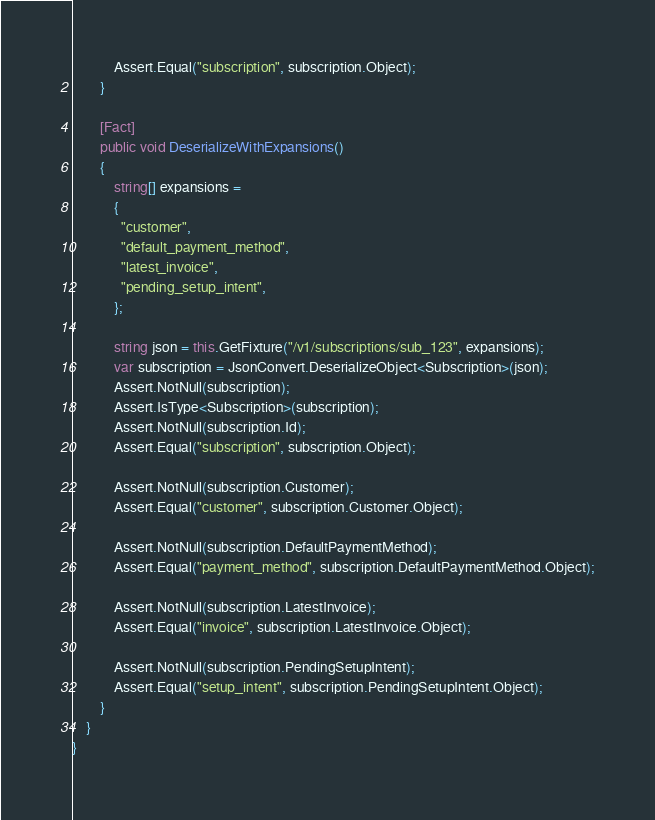<code> <loc_0><loc_0><loc_500><loc_500><_C#_>            Assert.Equal("subscription", subscription.Object);
        }

        [Fact]
        public void DeserializeWithExpansions()
        {
            string[] expansions =
            {
              "customer",
              "default_payment_method",
              "latest_invoice",
              "pending_setup_intent",
            };

            string json = this.GetFixture("/v1/subscriptions/sub_123", expansions);
            var subscription = JsonConvert.DeserializeObject<Subscription>(json);
            Assert.NotNull(subscription);
            Assert.IsType<Subscription>(subscription);
            Assert.NotNull(subscription.Id);
            Assert.Equal("subscription", subscription.Object);

            Assert.NotNull(subscription.Customer);
            Assert.Equal("customer", subscription.Customer.Object);

            Assert.NotNull(subscription.DefaultPaymentMethod);
            Assert.Equal("payment_method", subscription.DefaultPaymentMethod.Object);

            Assert.NotNull(subscription.LatestInvoice);
            Assert.Equal("invoice", subscription.LatestInvoice.Object);

            Assert.NotNull(subscription.PendingSetupIntent);
            Assert.Equal("setup_intent", subscription.PendingSetupIntent.Object);
        }
    }
}
</code> 